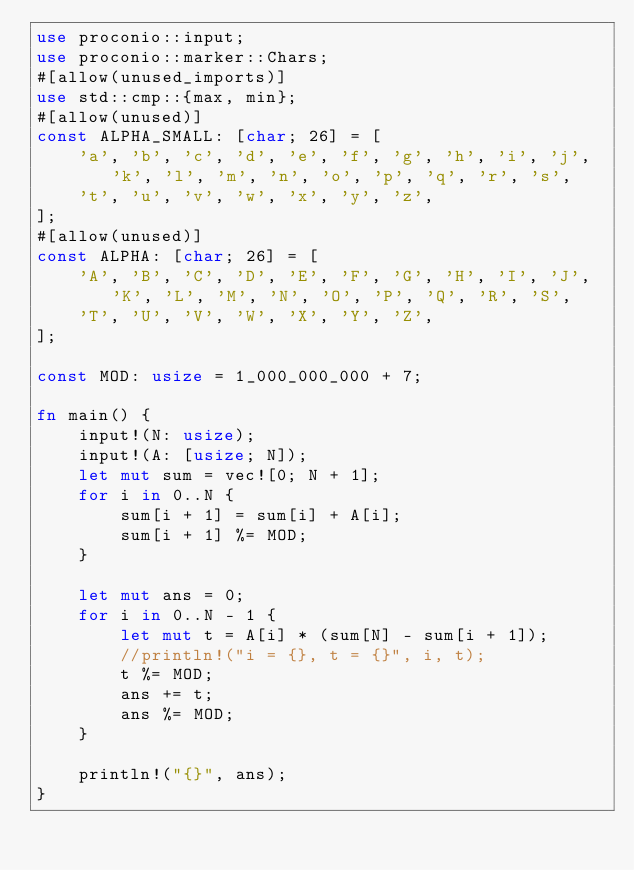<code> <loc_0><loc_0><loc_500><loc_500><_Rust_>use proconio::input;
use proconio::marker::Chars;
#[allow(unused_imports)]
use std::cmp::{max, min};
#[allow(unused)]
const ALPHA_SMALL: [char; 26] = [
    'a', 'b', 'c', 'd', 'e', 'f', 'g', 'h', 'i', 'j', 'k', 'l', 'm', 'n', 'o', 'p', 'q', 'r', 's',
    't', 'u', 'v', 'w', 'x', 'y', 'z',
];
#[allow(unused)]
const ALPHA: [char; 26] = [
    'A', 'B', 'C', 'D', 'E', 'F', 'G', 'H', 'I', 'J', 'K', 'L', 'M', 'N', 'O', 'P', 'Q', 'R', 'S',
    'T', 'U', 'V', 'W', 'X', 'Y', 'Z',
];

const MOD: usize = 1_000_000_000 + 7;

fn main() {
    input!(N: usize);
    input!(A: [usize; N]);
    let mut sum = vec![0; N + 1];
    for i in 0..N {
        sum[i + 1] = sum[i] + A[i];
        sum[i + 1] %= MOD;
    }

    let mut ans = 0;
    for i in 0..N - 1 {
        let mut t = A[i] * (sum[N] - sum[i + 1]);
        //println!("i = {}, t = {}", i, t);
        t %= MOD;
        ans += t;
        ans %= MOD;
    }

    println!("{}", ans);
}
</code> 